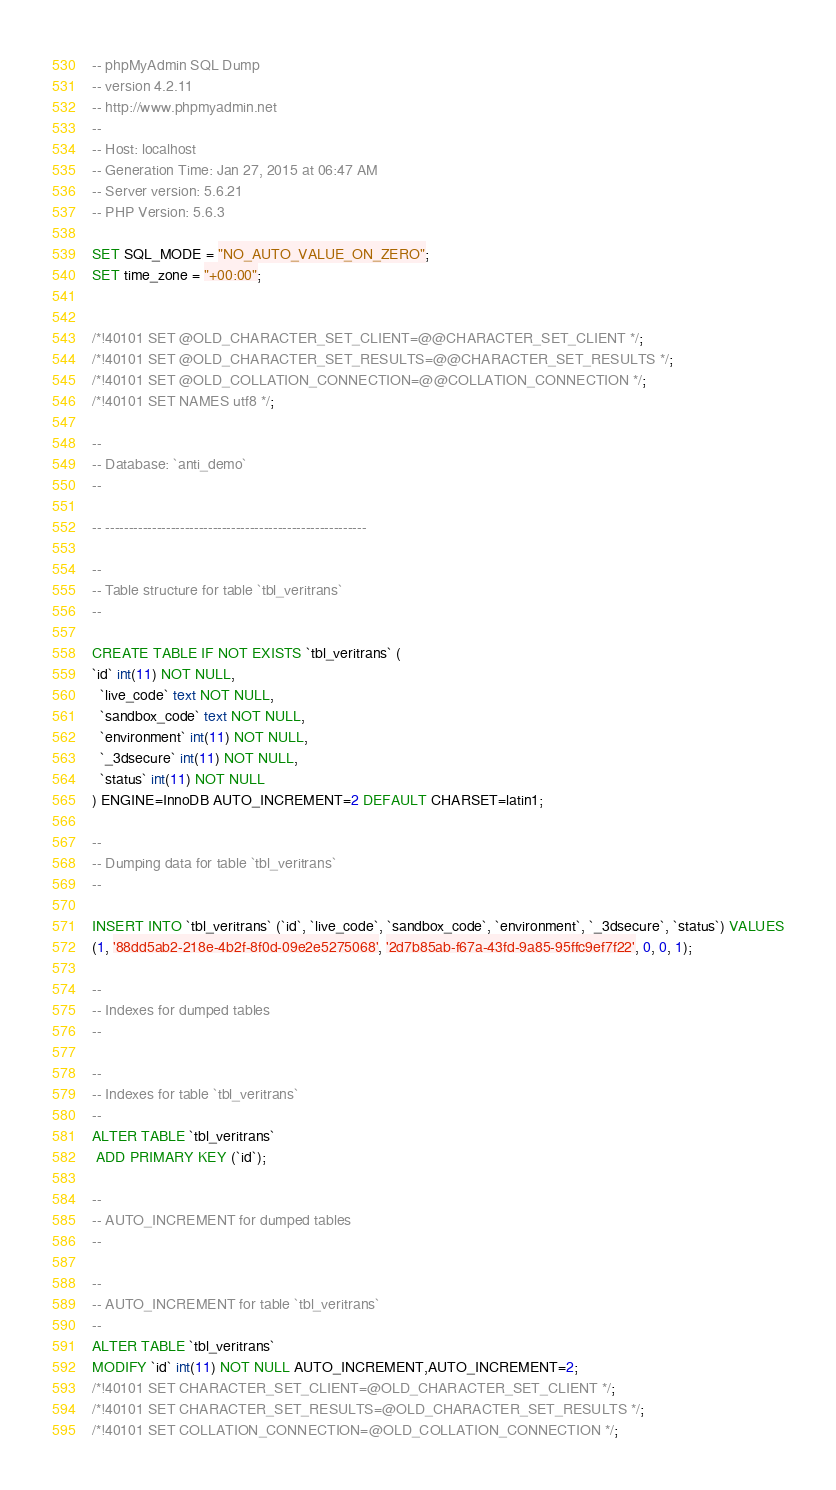<code> <loc_0><loc_0><loc_500><loc_500><_SQL_>-- phpMyAdmin SQL Dump
-- version 4.2.11
-- http://www.phpmyadmin.net
--
-- Host: localhost
-- Generation Time: Jan 27, 2015 at 06:47 AM
-- Server version: 5.6.21
-- PHP Version: 5.6.3

SET SQL_MODE = "NO_AUTO_VALUE_ON_ZERO";
SET time_zone = "+00:00";


/*!40101 SET @OLD_CHARACTER_SET_CLIENT=@@CHARACTER_SET_CLIENT */;
/*!40101 SET @OLD_CHARACTER_SET_RESULTS=@@CHARACTER_SET_RESULTS */;
/*!40101 SET @OLD_COLLATION_CONNECTION=@@COLLATION_CONNECTION */;
/*!40101 SET NAMES utf8 */;

--
-- Database: `anti_demo`
--

-- --------------------------------------------------------

--
-- Table structure for table `tbl_veritrans`
--

CREATE TABLE IF NOT EXISTS `tbl_veritrans` (
`id` int(11) NOT NULL,
  `live_code` text NOT NULL,
  `sandbox_code` text NOT NULL,
  `environment` int(11) NOT NULL,
  `_3dsecure` int(11) NOT NULL,
  `status` int(11) NOT NULL
) ENGINE=InnoDB AUTO_INCREMENT=2 DEFAULT CHARSET=latin1;

--
-- Dumping data for table `tbl_veritrans`
--

INSERT INTO `tbl_veritrans` (`id`, `live_code`, `sandbox_code`, `environment`, `_3dsecure`, `status`) VALUES
(1, '88dd5ab2-218e-4b2f-8f0d-09e2e5275068', '2d7b85ab-f67a-43fd-9a85-95ffc9ef7f22', 0, 0, 1);

--
-- Indexes for dumped tables
--

--
-- Indexes for table `tbl_veritrans`
--
ALTER TABLE `tbl_veritrans`
 ADD PRIMARY KEY (`id`);

--
-- AUTO_INCREMENT for dumped tables
--

--
-- AUTO_INCREMENT for table `tbl_veritrans`
--
ALTER TABLE `tbl_veritrans`
MODIFY `id` int(11) NOT NULL AUTO_INCREMENT,AUTO_INCREMENT=2;
/*!40101 SET CHARACTER_SET_CLIENT=@OLD_CHARACTER_SET_CLIENT */;
/*!40101 SET CHARACTER_SET_RESULTS=@OLD_CHARACTER_SET_RESULTS */;
/*!40101 SET COLLATION_CONNECTION=@OLD_COLLATION_CONNECTION */;
</code> 